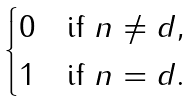Convert formula to latex. <formula><loc_0><loc_0><loc_500><loc_500>\begin{cases} 0 & \text {if $n\neq d$} , \\ 1 & \text {if $n = d$} . \end{cases}</formula> 